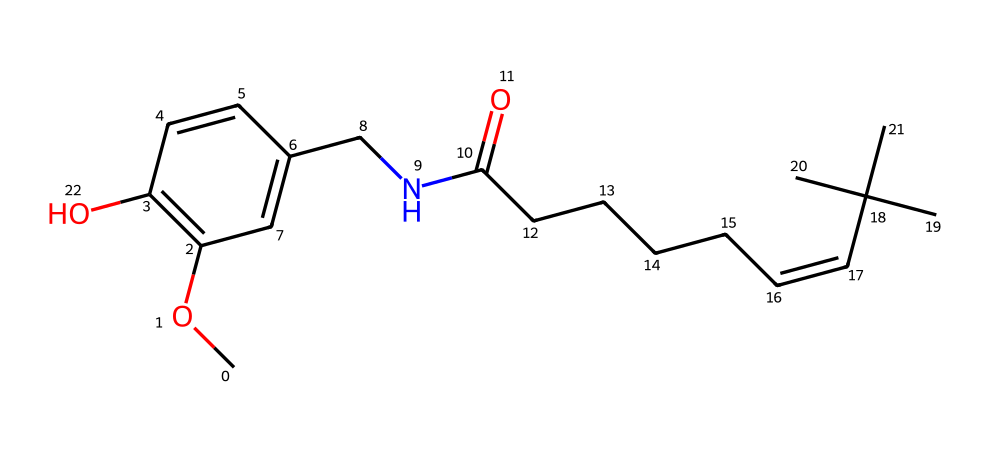What is the main functional group present in capsaicin? The structure includes an amide linkage (the nitrogen connected to the carbonyl), which is characteristic of amides. This is indicated by the presence of nitrogen bonded to a carbonyl carbon.
Answer: amide How many carbon atoms are in the capsaicin molecule? By counting the number of carbon atoms present in the SMILES representation, we can identify that there are 18 carbon atoms, which are depicted along the structure.
Answer: 18 What type of lipid does capsaicin belong to? Considering the structure, capsaicin is categorized as a non-glycerol lipid based on its long carbon chain and amide functional group, distinguishing it from glycerol-based lipids.
Answer: non-glycerol lipid What is the total number of double bonds in capsaicin? The analysis of the SMILES shows that there are two double bonds present between carbon atoms in the hydrocarbon chain and the aromatic ring in the structure.
Answer: 2 Which part of the molecule contributes to its pharmacological action? The aromatic portion of the molecule, specifically the phenolic structure (the ring with alternating double bonds), plays a crucial role in the interaction with pain receptors, contributing to its medicinal effects.
Answer: phenolic structure What element is present in capsaicin that is not seen in many other lipids? The presence of nitrogen in the structure is notable as it differentiates capsaicin from most common lipid molecules, which typically comprise only carbon, hydrogen, and oxygen.
Answer: nitrogen 